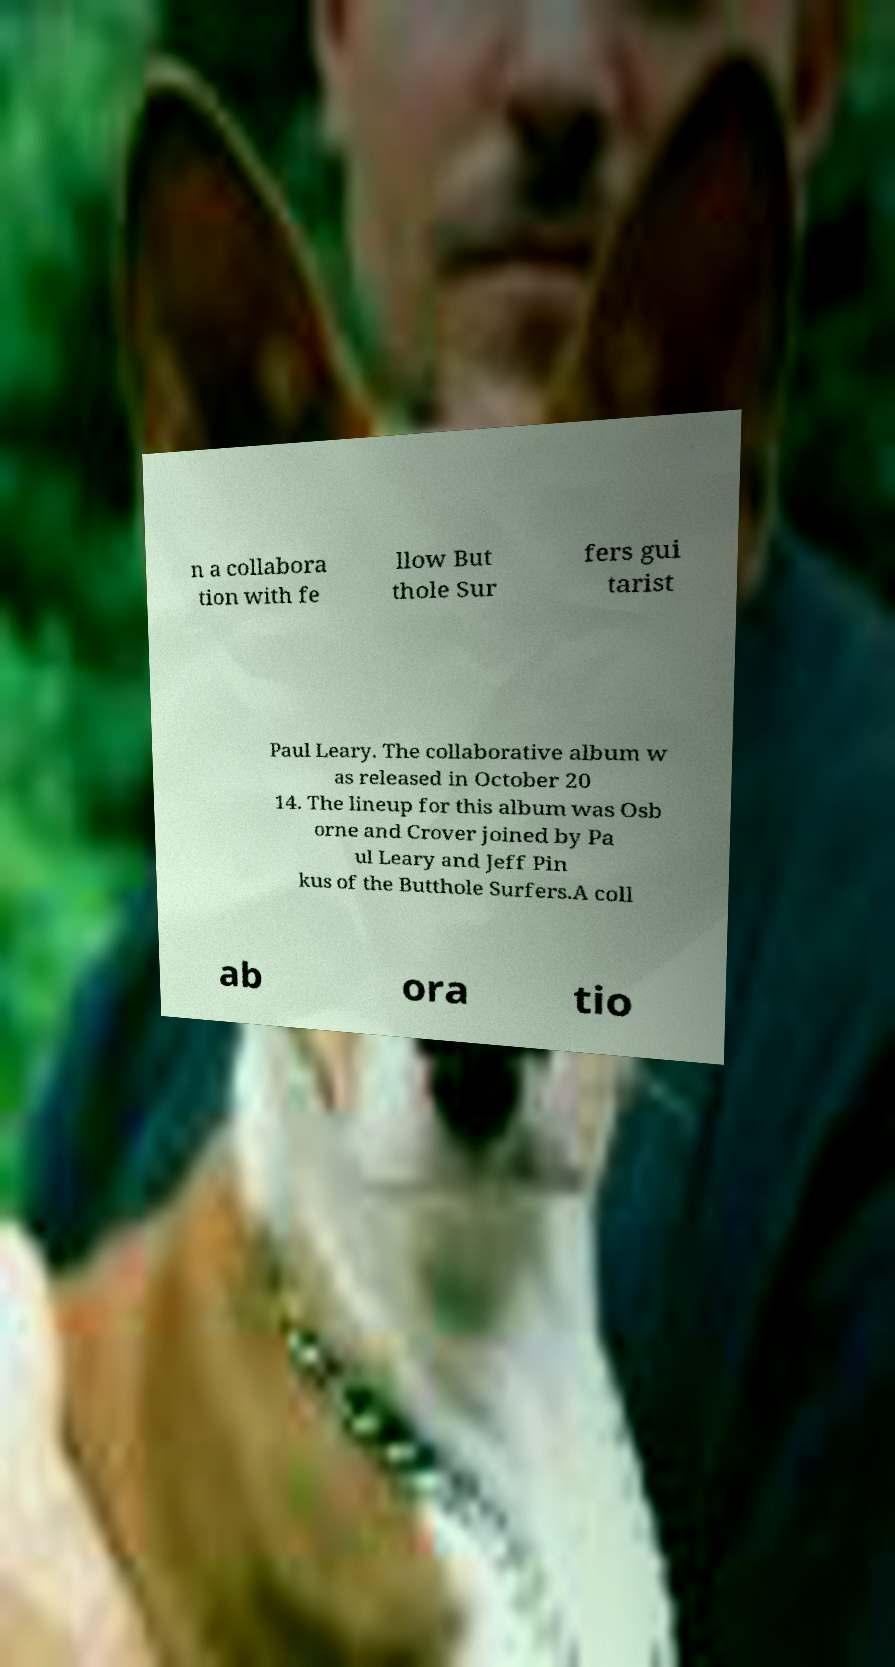Could you assist in decoding the text presented in this image and type it out clearly? n a collabora tion with fe llow But thole Sur fers gui tarist Paul Leary. The collaborative album w as released in October 20 14. The lineup for this album was Osb orne and Crover joined by Pa ul Leary and Jeff Pin kus of the Butthole Surfers.A coll ab ora tio 